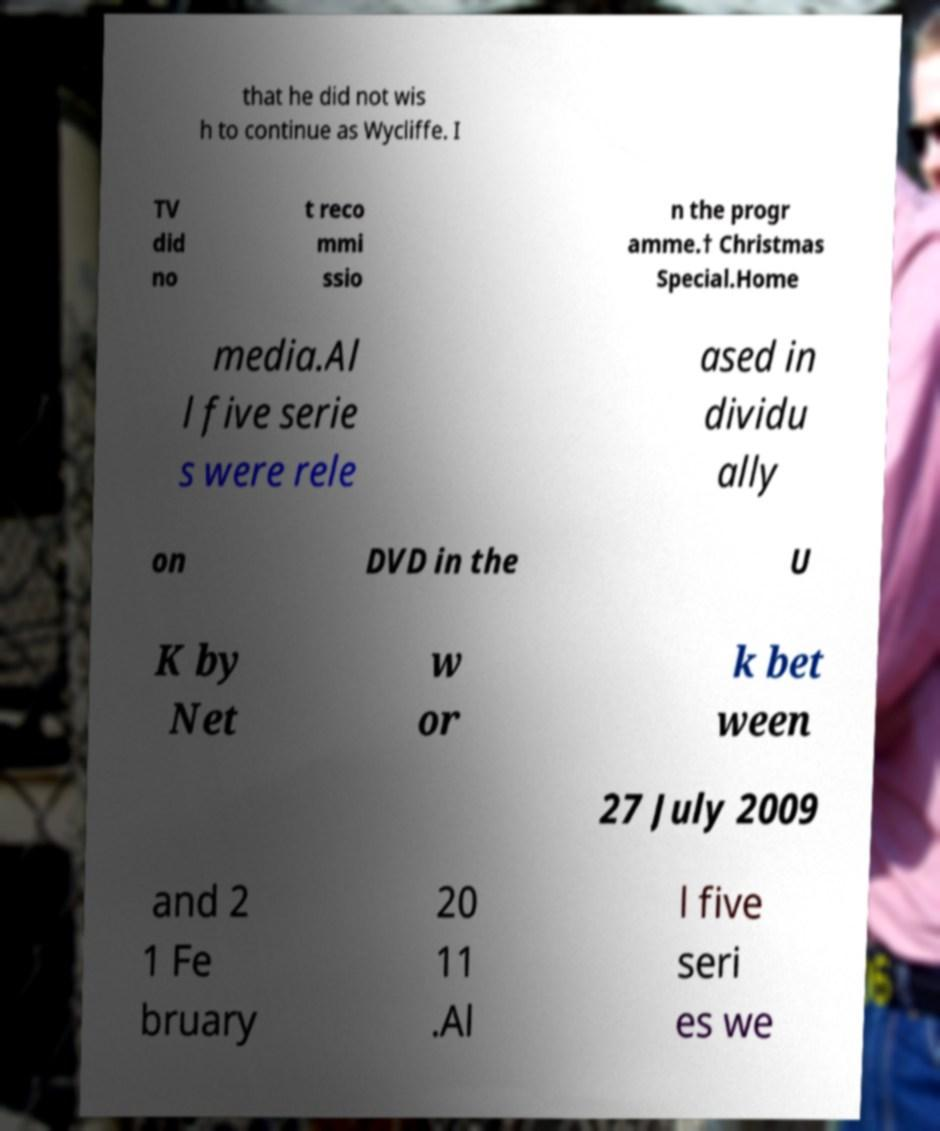Please identify and transcribe the text found in this image. that he did not wis h to continue as Wycliffe. I TV did no t reco mmi ssio n the progr amme.† Christmas Special.Home media.Al l five serie s were rele ased in dividu ally on DVD in the U K by Net w or k bet ween 27 July 2009 and 2 1 Fe bruary 20 11 .Al l five seri es we 